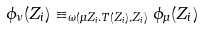Convert formula to latex. <formula><loc_0><loc_0><loc_500><loc_500>\phi _ { \nu } ( Z _ { i } ) \equiv _ { \omega ( \mu Z _ { i } . T ( Z _ { i } ) , Z _ { i } ) } \phi _ { \mu } ( Z _ { i } )</formula> 